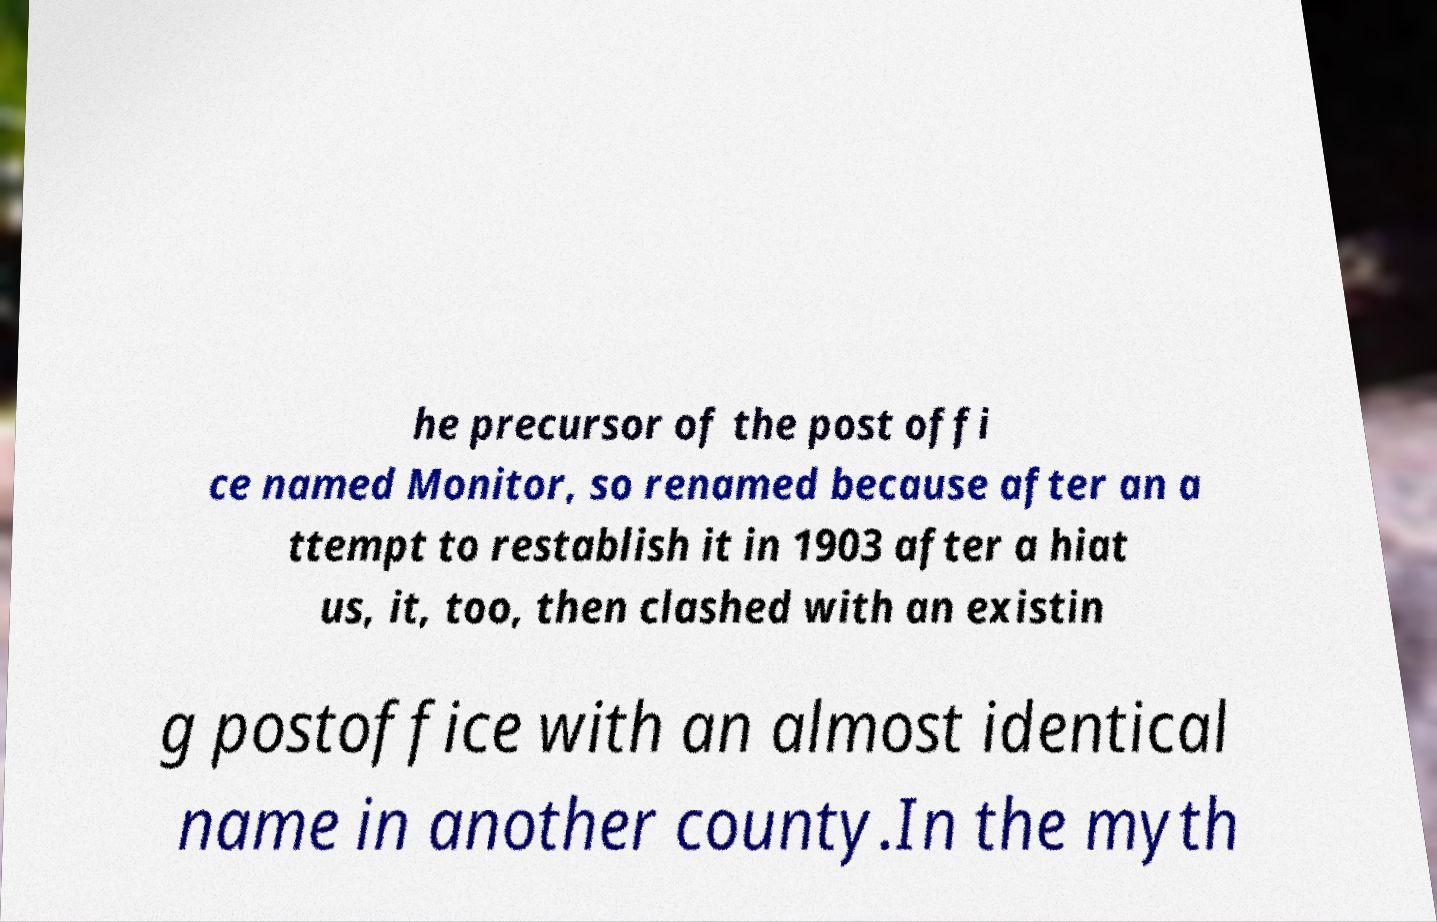I need the written content from this picture converted into text. Can you do that? he precursor of the post offi ce named Monitor, so renamed because after an a ttempt to restablish it in 1903 after a hiat us, it, too, then clashed with an existin g postoffice with an almost identical name in another county.In the myth 